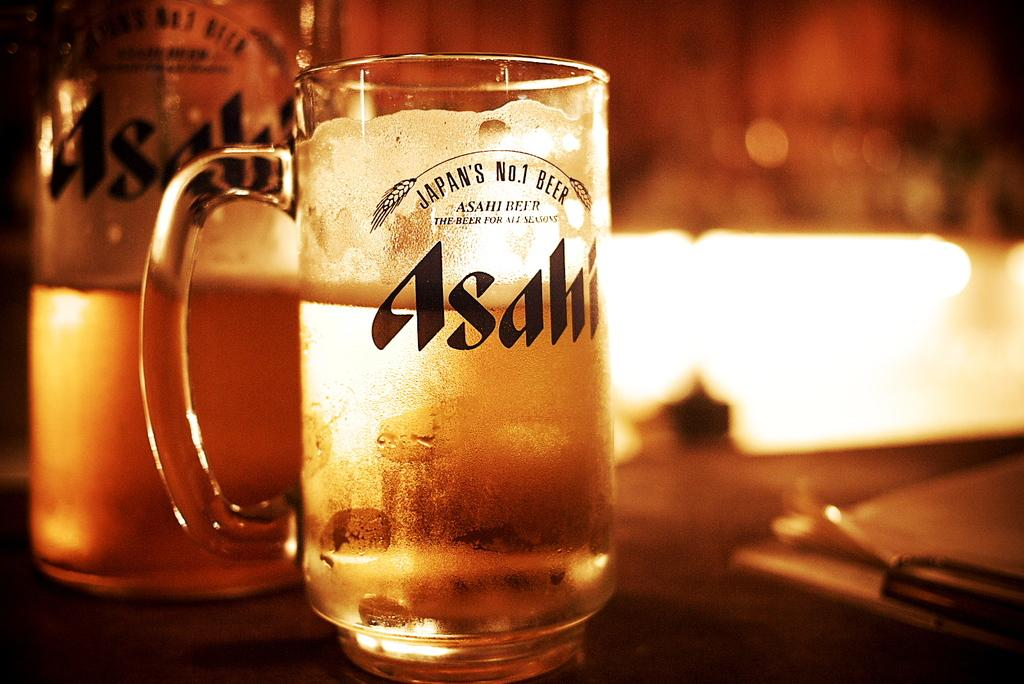Provide a one-sentence caption for the provided image. A clear glass of Japan's No.1 Beer called Asahi is almost full. 